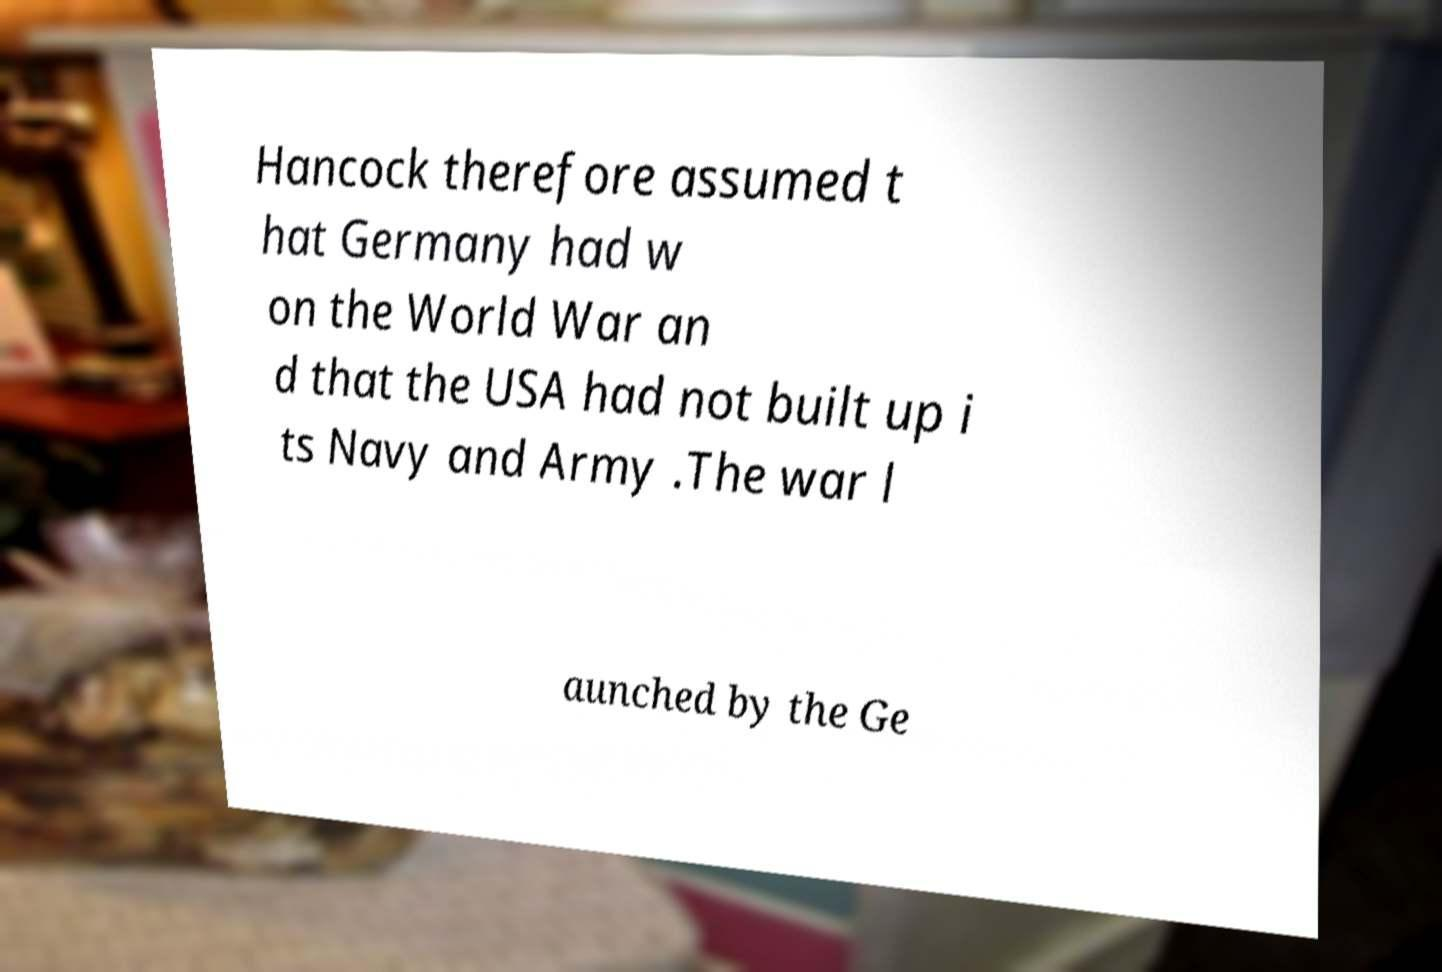Can you read and provide the text displayed in the image?This photo seems to have some interesting text. Can you extract and type it out for me? Hancock therefore assumed t hat Germany had w on the World War an d that the USA had not built up i ts Navy and Army .The war l aunched by the Ge 